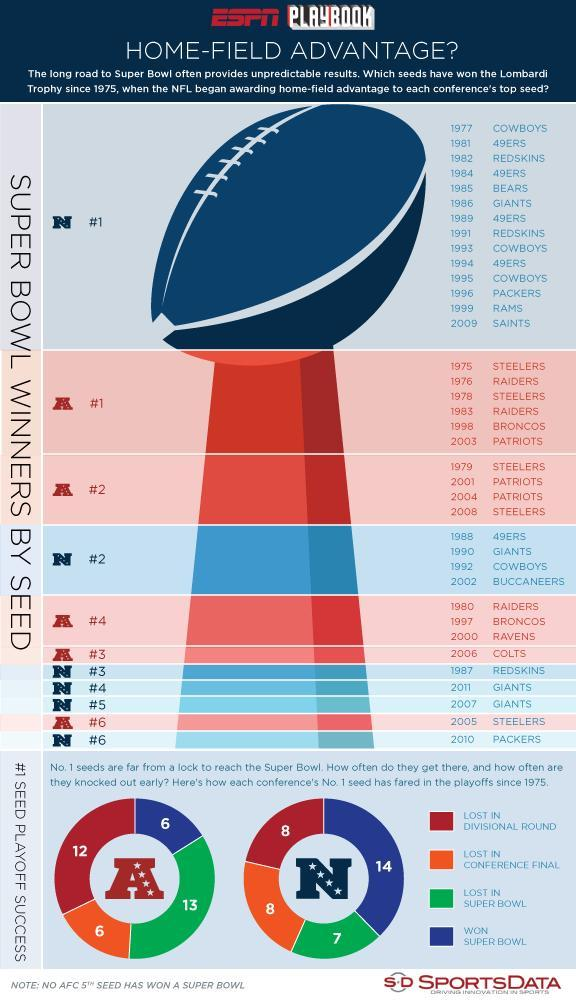What was the ranking of the Steelers in  American Football conference in 2008?
Answer the question with a short phrase. 2 Who was ranked number 2 in national football conference in 2002? Buccaneers How many games were won by the number one seed of National Football Conference playoffs? 14 How many games were lost by the number one seeds of American Football Conference playoffs? 13 